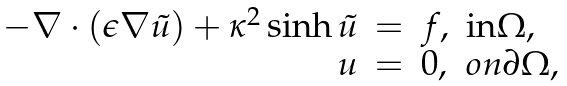<formula> <loc_0><loc_0><loc_500><loc_500>\begin{array} { r l l l } - \nabla \cdot ( \epsilon \nabla \tilde { u } ) + \kappa ^ { 2 } \sinh \tilde { u } & = & f , & \text {in} \Omega , \\ u & = & 0 , & o n \partial \Omega , \end{array}</formula> 